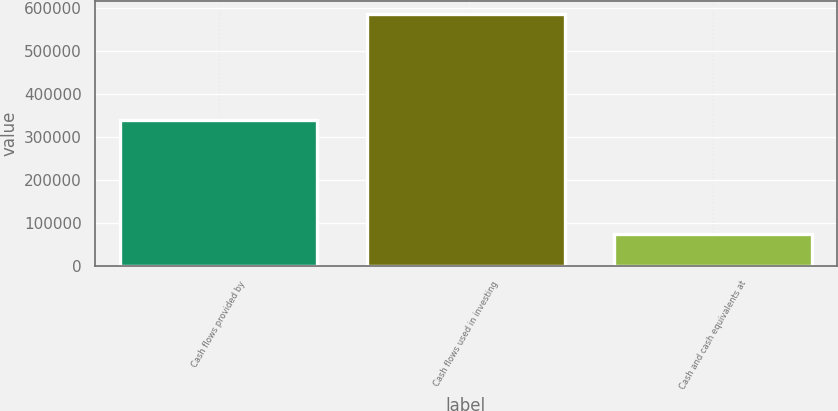<chart> <loc_0><loc_0><loc_500><loc_500><bar_chart><fcel>Cash flows provided by<fcel>Cash flows used in investing<fcel>Cash and cash equivalents at<nl><fcel>339888<fcel>586634<fcel>74683<nl></chart> 